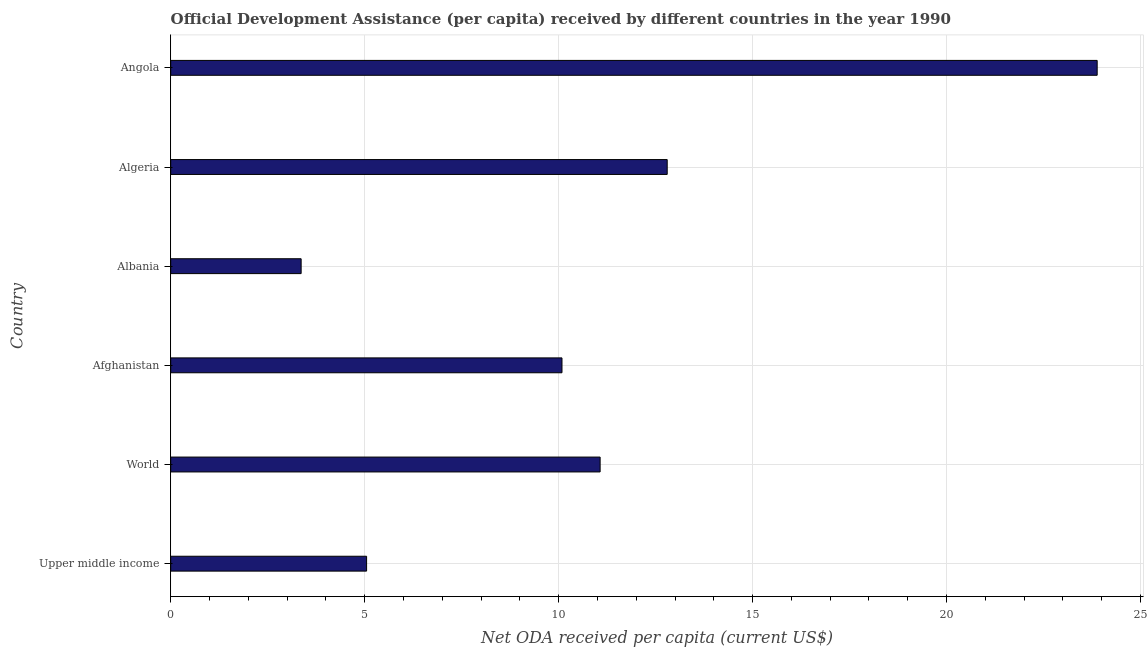What is the title of the graph?
Your response must be concise. Official Development Assistance (per capita) received by different countries in the year 1990. What is the label or title of the X-axis?
Your answer should be very brief. Net ODA received per capita (current US$). What is the label or title of the Y-axis?
Your answer should be very brief. Country. What is the net oda received per capita in Algeria?
Offer a terse response. 12.8. Across all countries, what is the maximum net oda received per capita?
Ensure brevity in your answer.  23.88. Across all countries, what is the minimum net oda received per capita?
Make the answer very short. 3.36. In which country was the net oda received per capita maximum?
Your answer should be very brief. Angola. In which country was the net oda received per capita minimum?
Your answer should be very brief. Albania. What is the sum of the net oda received per capita?
Offer a very short reply. 66.25. What is the difference between the net oda received per capita in Angola and World?
Your answer should be compact. 12.81. What is the average net oda received per capita per country?
Provide a short and direct response. 11.04. What is the median net oda received per capita?
Your answer should be very brief. 10.58. What is the ratio of the net oda received per capita in Albania to that in World?
Provide a succinct answer. 0.3. Is the difference between the net oda received per capita in Algeria and Angola greater than the difference between any two countries?
Ensure brevity in your answer.  No. What is the difference between the highest and the second highest net oda received per capita?
Provide a succinct answer. 11.08. What is the difference between the highest and the lowest net oda received per capita?
Ensure brevity in your answer.  20.52. In how many countries, is the net oda received per capita greater than the average net oda received per capita taken over all countries?
Your answer should be very brief. 3. How many countries are there in the graph?
Your response must be concise. 6. Are the values on the major ticks of X-axis written in scientific E-notation?
Offer a terse response. No. What is the Net ODA received per capita (current US$) in Upper middle income?
Make the answer very short. 5.05. What is the Net ODA received per capita (current US$) in World?
Your answer should be compact. 11.07. What is the Net ODA received per capita (current US$) in Afghanistan?
Provide a succinct answer. 10.09. What is the Net ODA received per capita (current US$) of Albania?
Offer a very short reply. 3.36. What is the Net ODA received per capita (current US$) of Algeria?
Provide a short and direct response. 12.8. What is the Net ODA received per capita (current US$) in Angola?
Your answer should be compact. 23.88. What is the difference between the Net ODA received per capita (current US$) in Upper middle income and World?
Give a very brief answer. -6.02. What is the difference between the Net ODA received per capita (current US$) in Upper middle income and Afghanistan?
Keep it short and to the point. -5.04. What is the difference between the Net ODA received per capita (current US$) in Upper middle income and Albania?
Your response must be concise. 1.69. What is the difference between the Net ODA received per capita (current US$) in Upper middle income and Algeria?
Your answer should be compact. -7.75. What is the difference between the Net ODA received per capita (current US$) in Upper middle income and Angola?
Provide a succinct answer. -18.83. What is the difference between the Net ODA received per capita (current US$) in World and Afghanistan?
Provide a short and direct response. 0.98. What is the difference between the Net ODA received per capita (current US$) in World and Albania?
Your answer should be very brief. 7.71. What is the difference between the Net ODA received per capita (current US$) in World and Algeria?
Your answer should be very brief. -1.73. What is the difference between the Net ODA received per capita (current US$) in World and Angola?
Your answer should be very brief. -12.81. What is the difference between the Net ODA received per capita (current US$) in Afghanistan and Albania?
Offer a very short reply. 6.72. What is the difference between the Net ODA received per capita (current US$) in Afghanistan and Algeria?
Give a very brief answer. -2.71. What is the difference between the Net ODA received per capita (current US$) in Afghanistan and Angola?
Give a very brief answer. -13.8. What is the difference between the Net ODA received per capita (current US$) in Albania and Algeria?
Provide a short and direct response. -9.44. What is the difference between the Net ODA received per capita (current US$) in Albania and Angola?
Your response must be concise. -20.52. What is the difference between the Net ODA received per capita (current US$) in Algeria and Angola?
Provide a succinct answer. -11.08. What is the ratio of the Net ODA received per capita (current US$) in Upper middle income to that in World?
Offer a terse response. 0.46. What is the ratio of the Net ODA received per capita (current US$) in Upper middle income to that in Afghanistan?
Offer a very short reply. 0.5. What is the ratio of the Net ODA received per capita (current US$) in Upper middle income to that in Albania?
Your answer should be very brief. 1.5. What is the ratio of the Net ODA received per capita (current US$) in Upper middle income to that in Algeria?
Ensure brevity in your answer.  0.4. What is the ratio of the Net ODA received per capita (current US$) in Upper middle income to that in Angola?
Your answer should be very brief. 0.21. What is the ratio of the Net ODA received per capita (current US$) in World to that in Afghanistan?
Ensure brevity in your answer.  1.1. What is the ratio of the Net ODA received per capita (current US$) in World to that in Albania?
Keep it short and to the point. 3.29. What is the ratio of the Net ODA received per capita (current US$) in World to that in Algeria?
Give a very brief answer. 0.86. What is the ratio of the Net ODA received per capita (current US$) in World to that in Angola?
Your answer should be very brief. 0.46. What is the ratio of the Net ODA received per capita (current US$) in Afghanistan to that in Albania?
Offer a very short reply. 3. What is the ratio of the Net ODA received per capita (current US$) in Afghanistan to that in Algeria?
Your response must be concise. 0.79. What is the ratio of the Net ODA received per capita (current US$) in Afghanistan to that in Angola?
Make the answer very short. 0.42. What is the ratio of the Net ODA received per capita (current US$) in Albania to that in Algeria?
Make the answer very short. 0.26. What is the ratio of the Net ODA received per capita (current US$) in Albania to that in Angola?
Your answer should be very brief. 0.14. What is the ratio of the Net ODA received per capita (current US$) in Algeria to that in Angola?
Your response must be concise. 0.54. 